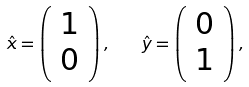<formula> <loc_0><loc_0><loc_500><loc_500>\hat { x } = \left ( \begin{array} { c } 1 \\ 0 \\ \end{array} \right ) , \quad \hat { y } = \left ( \begin{array} { c } 0 \\ 1 \\ \end{array} \right ) ,</formula> 